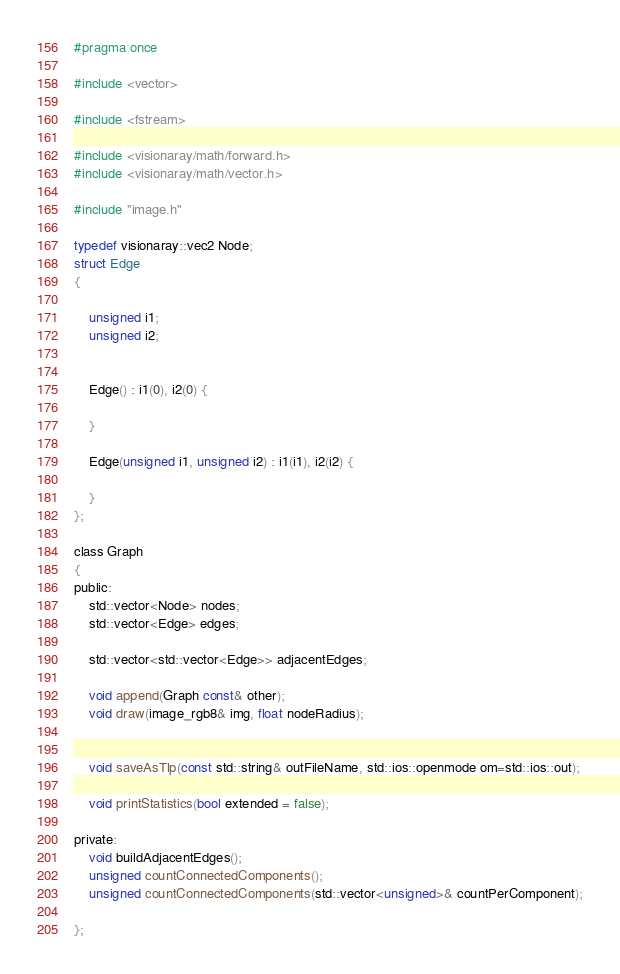Convert code to text. <code><loc_0><loc_0><loc_500><loc_500><_C_>#pragma once

#include <vector>

#include <fstream>

#include <visionaray/math/forward.h>
#include <visionaray/math/vector.h>

#include "image.h"

typedef visionaray::vec2 Node;
struct Edge
{

    unsigned i1;
    unsigned i2;


    Edge() : i1(0), i2(0) {

    }

    Edge(unsigned i1, unsigned i2) : i1(i1), i2(i2) {

    }
};

class Graph
{
public:
    std::vector<Node> nodes;
    std::vector<Edge> edges;

    std::vector<std::vector<Edge>> adjacentEdges;

    void append(Graph const& other);
    void draw(image_rgb8& img, float nodeRadius);


    void saveAsTlp(const std::string& outFileName, std::ios::openmode om=std::ios::out);

    void printStatistics(bool extended = false);

private:
    void buildAdjacentEdges();
    unsigned countConnectedComponents();
    unsigned countConnectedComponents(std::vector<unsigned>& countPerComponent);

};
</code> 